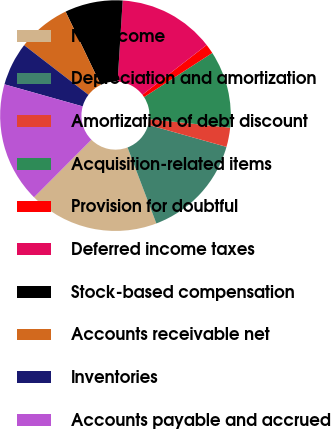Convert chart to OTSL. <chart><loc_0><loc_0><loc_500><loc_500><pie_chart><fcel>Net income<fcel>Depreciation and amortization<fcel>Amortization of debt discount<fcel>Acquisition-related items<fcel>Provision for doubtful<fcel>Deferred income taxes<fcel>Stock-based compensation<fcel>Accounts receivable net<fcel>Inventories<fcel>Accounts payable and accrued<nl><fcel>18.24%<fcel>14.86%<fcel>2.7%<fcel>10.81%<fcel>1.35%<fcel>13.51%<fcel>8.11%<fcel>7.43%<fcel>6.08%<fcel>16.89%<nl></chart> 